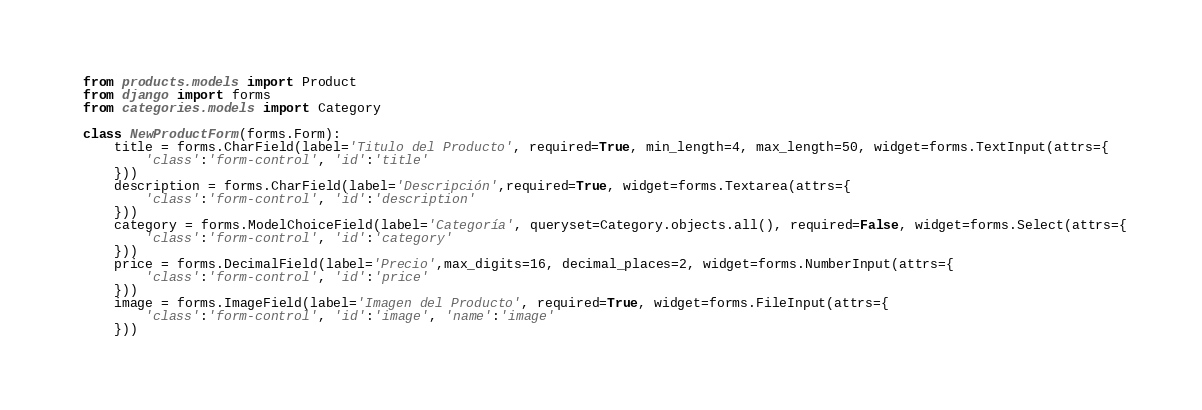Convert code to text. <code><loc_0><loc_0><loc_500><loc_500><_Python_>from products.models import Product
from django import forms
from categories.models import Category

class NewProductForm(forms.Form):
    title = forms.CharField(label='Titulo del Producto', required=True, min_length=4, max_length=50, widget=forms.TextInput(attrs={
        'class':'form-control', 'id':'title'
    }))
    description = forms.CharField(label='Descripción',required=True, widget=forms.Textarea(attrs={
        'class':'form-control', 'id':'description'
    }))
    category = forms.ModelChoiceField(label='Categoría', queryset=Category.objects.all(), required=False, widget=forms.Select(attrs={
        'class':'form-control', 'id':'category'
    }))
    price = forms.DecimalField(label='Precio',max_digits=16, decimal_places=2, widget=forms.NumberInput(attrs={
        'class':'form-control', 'id':'price'
    }))
    image = forms.ImageField(label='Imagen del Producto', required=True, widget=forms.FileInput(attrs={
        'class':'form-control', 'id':'image', 'name':'image'
    }))</code> 